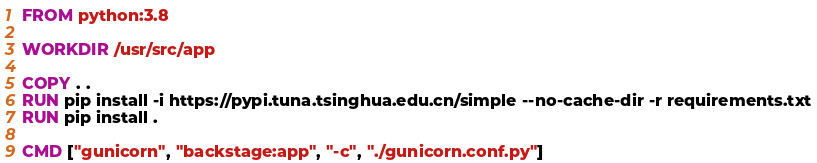Convert code to text. <code><loc_0><loc_0><loc_500><loc_500><_Dockerfile_>FROM python:3.8

WORKDIR /usr/src/app

COPY . .
RUN pip install -i https://pypi.tuna.tsinghua.edu.cn/simple --no-cache-dir -r requirements.txt
RUN pip install .

CMD ["gunicorn", "backstage:app", "-c", "./gunicorn.conf.py"]

</code> 